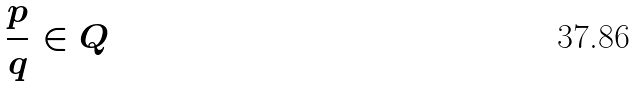<formula> <loc_0><loc_0><loc_500><loc_500>\frac { p } { q } \in Q</formula> 